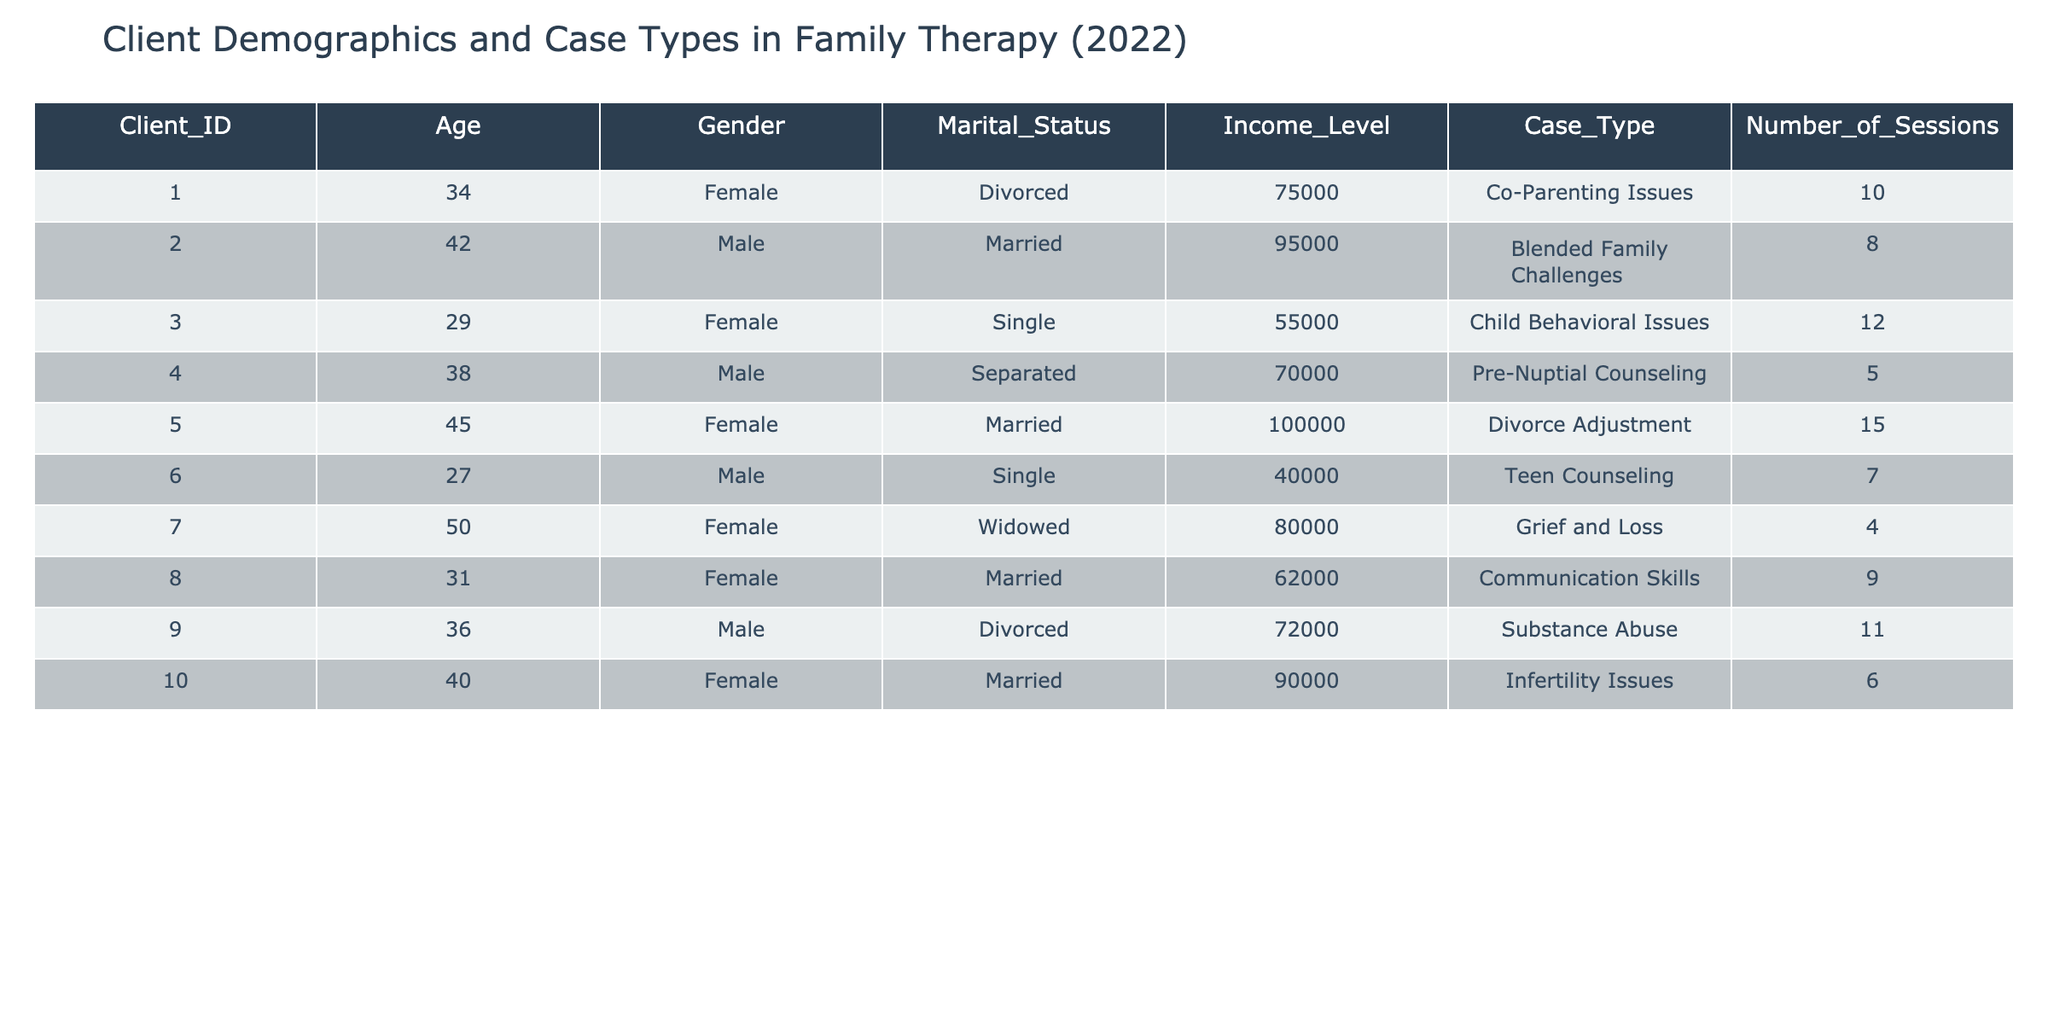What is the income level of the client with ID 5? By checking the table, the client with ID 5 has an income level listed as 100000.
Answer: 100000 How many sessions did the client aged 36 attend? Looking at the table, the client aged 36 has attended 11 sessions as indicated in the 'Number_of_Sessions' column.
Answer: 11 Which case type is the only one associated with a widowed client? The table shows that the client who is widowed (client ID 7) is associated with the case type "Grief and Loss."
Answer: Grief and Loss What is the average age of all clients in the table? The ages of the clients are (34, 42, 29, 38, 45, 27, 50, 31, 36, 40). Summing these gives 402, and there are 10 clients, so the average age is 402 divided by 10, which equals 40.2.
Answer: 40.2 Is there any male client with an income level less than 50000? Referring to the table, the only male client with an income listed is client ID 6, who has an income of 40000, which is less than 50000. Therefore, the answer is yes.
Answer: Yes Which marital status has the highest number of total sessions? We will need to sum the number of sessions by marital status: Divorced (10+11), Married (8+15+6+9), Single (12+7), Separated (5), and Widowed (4). The sums are: Divorced = 21, Married = 38, Single = 19, Separated = 5, Widowed = 4. Married has the highest total with 38 sessions.
Answer: Married How many clients attended more than 10 sessions? By reviewing the 'Number_of_Sessions' column, the clients who attended more than 10 sessions are clients ID 1, 3, 5, and 9. In total, there are 4 clients who attended more than 10 sessions.
Answer: 4 What percentage of clients are single? There are 2 single clients (IDs 3 and 6) out of a total of 10 clients. Therefore, the percentage of single clients is (2/10)*100 = 20 percent.
Answer: 20% Which case type has the highest session count? We can check the 'Number_of_Sessions' for each case type: Co-Parenting Issues (10), Blended Family Challenges (8), Child Behavioral Issues (12), Pre-Nuptial Counseling (5), Divorce Adjustment (15), Teen Counseling (7), Grief and Loss (4), Communication Skills (9), Substance Abuse (11), Infertility Issues (6). The case type "Divorce Adjustment" has the highest session count of 15.
Answer: Divorce Adjustment 